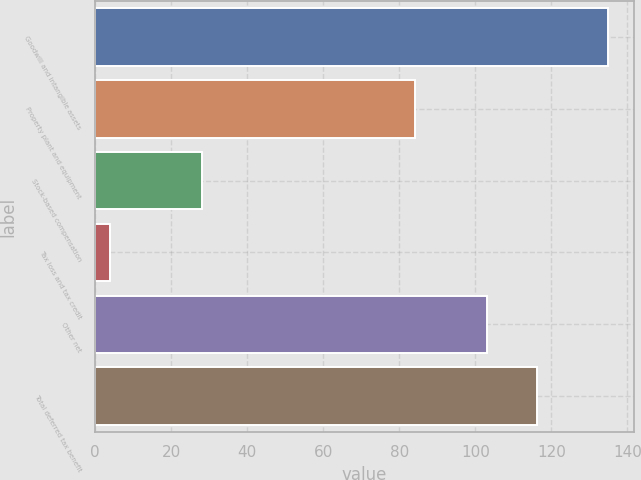Convert chart. <chart><loc_0><loc_0><loc_500><loc_500><bar_chart><fcel>Goodwill and intangible assets<fcel>Property plant and equipment<fcel>Stock-based compensation<fcel>Tax loss and tax credit<fcel>Other net<fcel>Total deferred tax benefit<nl><fcel>135<fcel>84<fcel>28<fcel>4<fcel>103<fcel>116.1<nl></chart> 